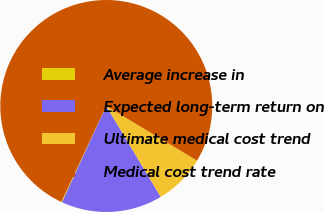Convert chart. <chart><loc_0><loc_0><loc_500><loc_500><pie_chart><fcel>Average increase in<fcel>Expected long-term return on<fcel>Ultimate medical cost trend<fcel>Medical cost trend rate<nl><fcel>0.13%<fcel>15.44%<fcel>7.78%<fcel>76.65%<nl></chart> 